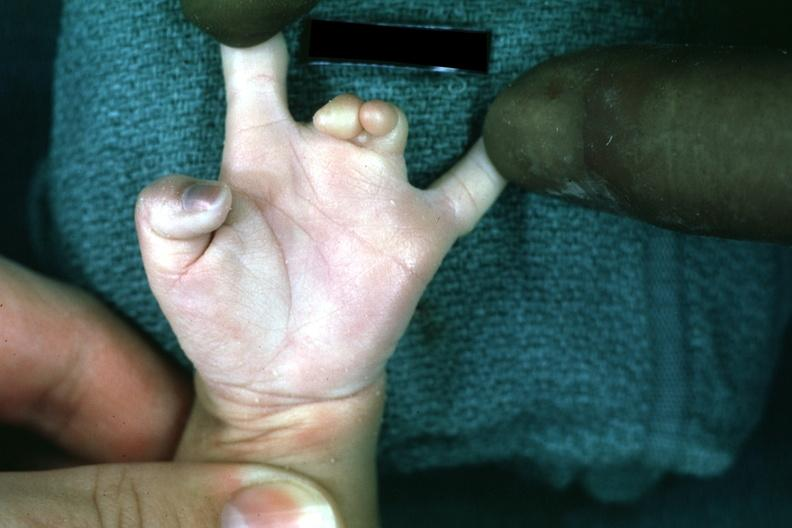what is present?
Answer the question using a single word or phrase. Hand 